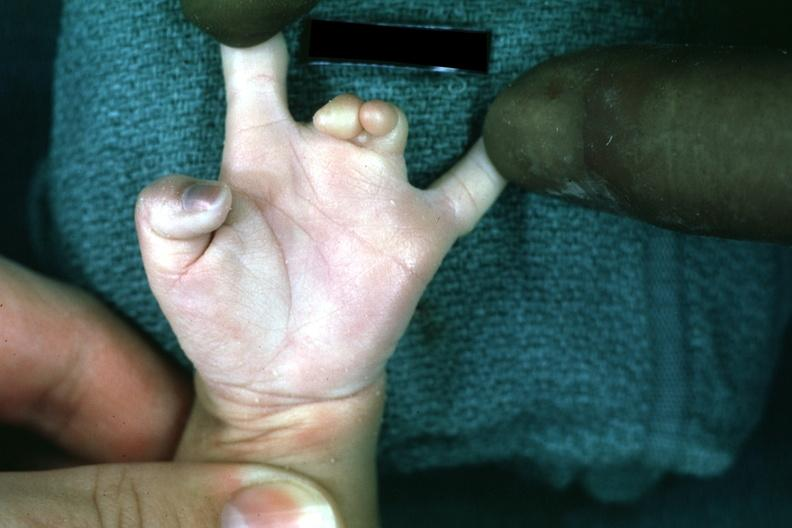what is present?
Answer the question using a single word or phrase. Hand 